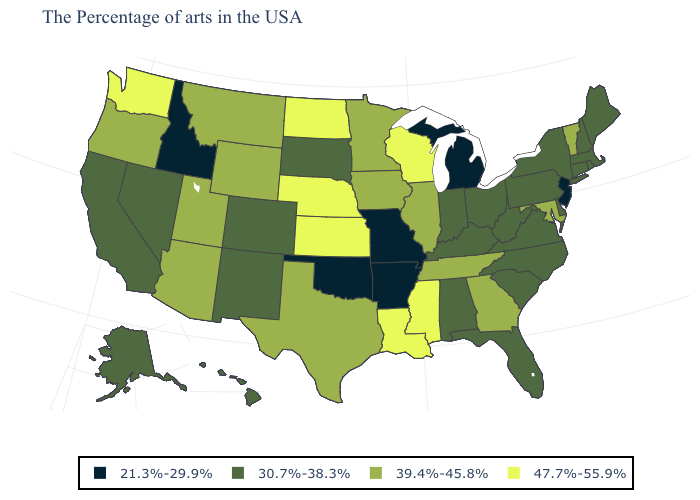Name the states that have a value in the range 21.3%-29.9%?
Give a very brief answer. New Jersey, Michigan, Missouri, Arkansas, Oklahoma, Idaho. Is the legend a continuous bar?
Concise answer only. No. Does South Dakota have the highest value in the USA?
Be succinct. No. Name the states that have a value in the range 47.7%-55.9%?
Quick response, please. Wisconsin, Mississippi, Louisiana, Kansas, Nebraska, North Dakota, Washington. Among the states that border Florida , which have the highest value?
Short answer required. Georgia. Among the states that border South Carolina , which have the lowest value?
Quick response, please. North Carolina. Does Alabama have the same value as Rhode Island?
Quick response, please. Yes. Does Louisiana have a higher value than Georgia?
Answer briefly. Yes. Name the states that have a value in the range 39.4%-45.8%?
Short answer required. Vermont, Maryland, Georgia, Tennessee, Illinois, Minnesota, Iowa, Texas, Wyoming, Utah, Montana, Arizona, Oregon. Does the map have missing data?
Be succinct. No. Which states have the highest value in the USA?
Quick response, please. Wisconsin, Mississippi, Louisiana, Kansas, Nebraska, North Dakota, Washington. What is the value of Iowa?
Short answer required. 39.4%-45.8%. Name the states that have a value in the range 30.7%-38.3%?
Answer briefly. Maine, Massachusetts, Rhode Island, New Hampshire, Connecticut, New York, Delaware, Pennsylvania, Virginia, North Carolina, South Carolina, West Virginia, Ohio, Florida, Kentucky, Indiana, Alabama, South Dakota, Colorado, New Mexico, Nevada, California, Alaska, Hawaii. Does the first symbol in the legend represent the smallest category?
Be succinct. Yes. Does New Jersey have a higher value than Mississippi?
Short answer required. No. 